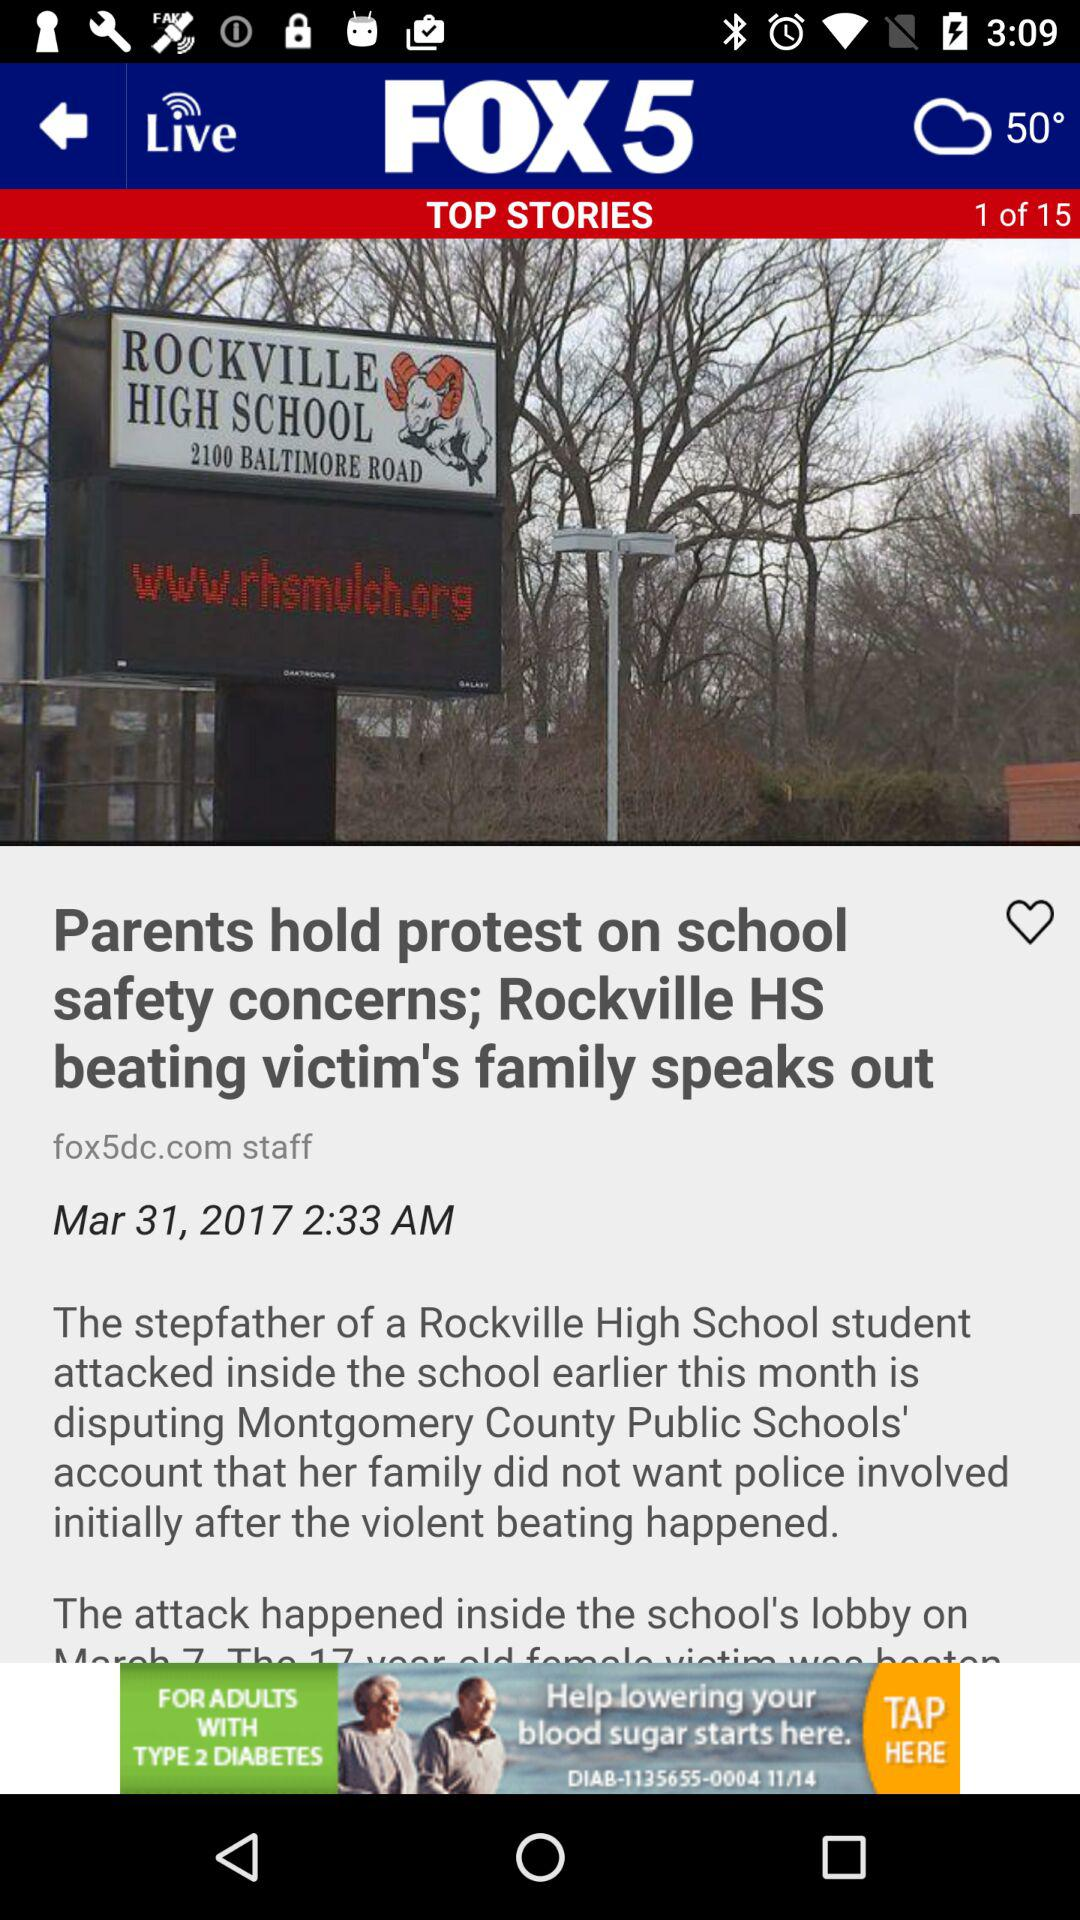What is the temperature? The temperature is 50°. 